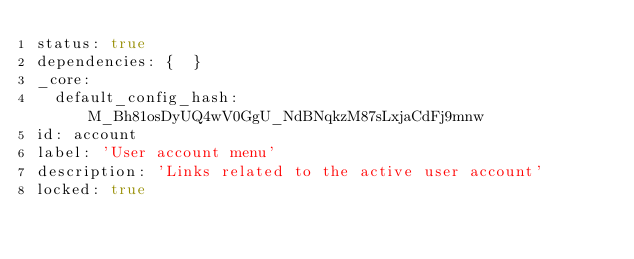<code> <loc_0><loc_0><loc_500><loc_500><_YAML_>status: true
dependencies: {  }
_core:
  default_config_hash: M_Bh81osDyUQ4wV0GgU_NdBNqkzM87sLxjaCdFj9mnw
id: account
label: 'User account menu'
description: 'Links related to the active user account'
locked: true
</code> 